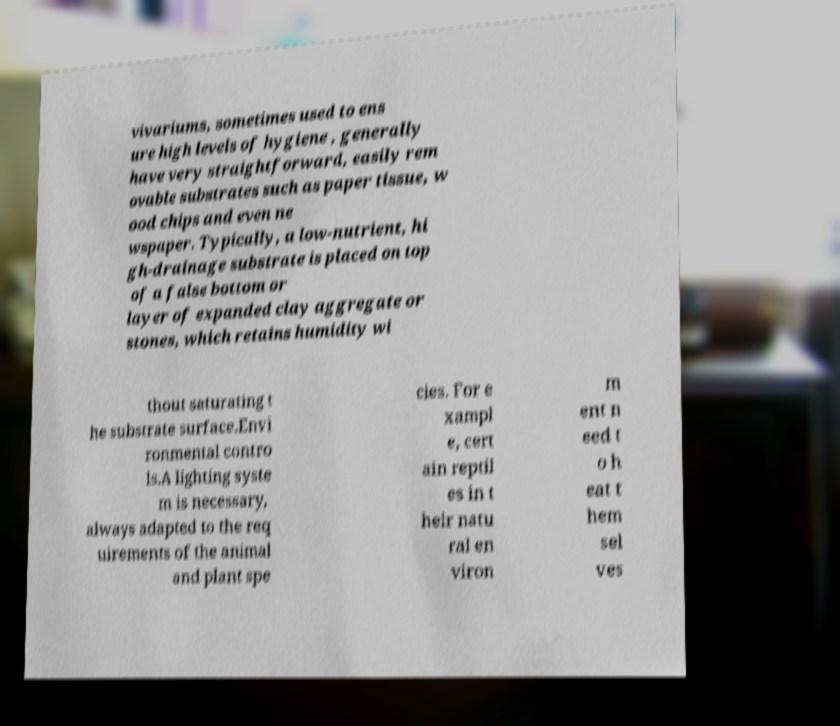Please read and relay the text visible in this image. What does it say? vivariums, sometimes used to ens ure high levels of hygiene , generally have very straightforward, easily rem ovable substrates such as paper tissue, w ood chips and even ne wspaper. Typically, a low-nutrient, hi gh-drainage substrate is placed on top of a false bottom or layer of expanded clay aggregate or stones, which retains humidity wi thout saturating t he substrate surface.Envi ronmental contro ls.A lighting syste m is necessary, always adapted to the req uirements of the animal and plant spe cies. For e xampl e, cert ain reptil es in t heir natu ral en viron m ent n eed t o h eat t hem sel ves 